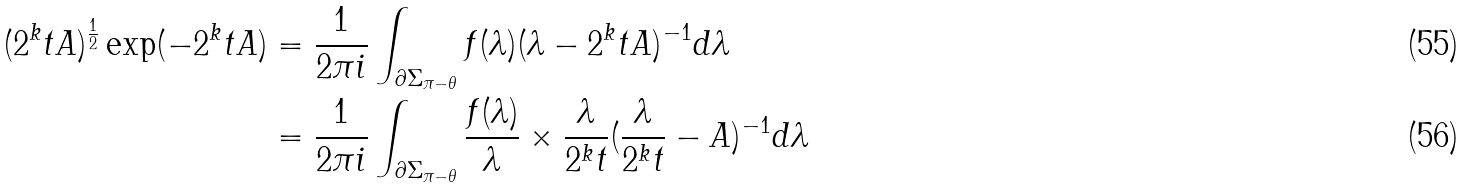<formula> <loc_0><loc_0><loc_500><loc_500>( 2 ^ { k } t A ) ^ { \frac { 1 } { 2 } } \exp ( - 2 ^ { k } t A ) & = \frac { 1 } { 2 \pi i } \int _ { \partial \Sigma _ { \pi - \theta } } f ( \lambda ) ( \lambda - 2 ^ { k } t A ) ^ { - 1 } d \lambda \\ & = \frac { 1 } { 2 \pi i } \int _ { \partial \Sigma _ { \pi - \theta } } \frac { f ( \lambda ) } { \lambda } \times \frac { \lambda } { 2 ^ { k } t } ( \frac { \lambda } { 2 ^ { k } t } - A ) ^ { - 1 } d \lambda</formula> 